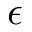<formula> <loc_0><loc_0><loc_500><loc_500>\epsilon</formula> 